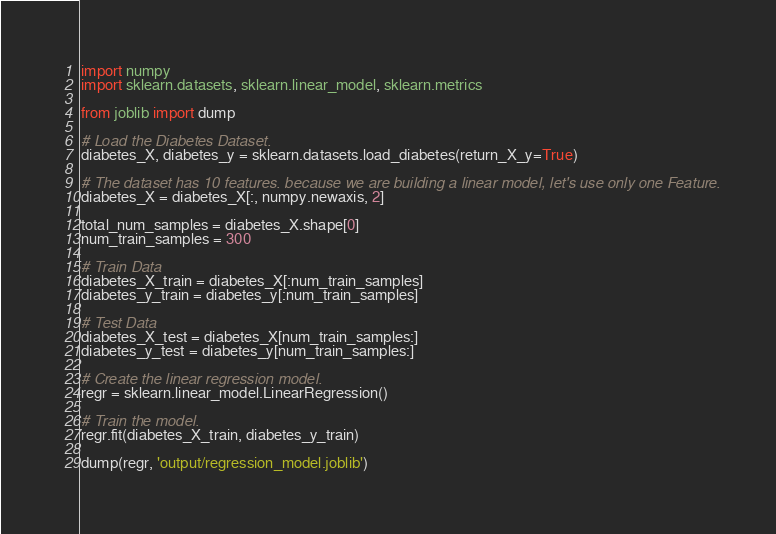Convert code to text. <code><loc_0><loc_0><loc_500><loc_500><_Python_>import numpy
import sklearn.datasets, sklearn.linear_model, sklearn.metrics

from joblib import dump

# Load the Diabetes Dataset.
diabetes_X, diabetes_y = sklearn.datasets.load_diabetes(return_X_y=True)

# The dataset has 10 features. because we are building a linear model, let's use only one Feature.
diabetes_X = diabetes_X[:, numpy.newaxis, 2]

total_num_samples = diabetes_X.shape[0]
num_train_samples = 300

# Train Data
diabetes_X_train = diabetes_X[:num_train_samples]
diabetes_y_train = diabetes_y[:num_train_samples]

# Test Data
diabetes_X_test = diabetes_X[num_train_samples:]
diabetes_y_test = diabetes_y[num_train_samples:]

# Create the linear regression model.
regr = sklearn.linear_model.LinearRegression()

# Train the model.
regr.fit(diabetes_X_train, diabetes_y_train)

dump(regr, 'output/regression_model.joblib')
</code> 